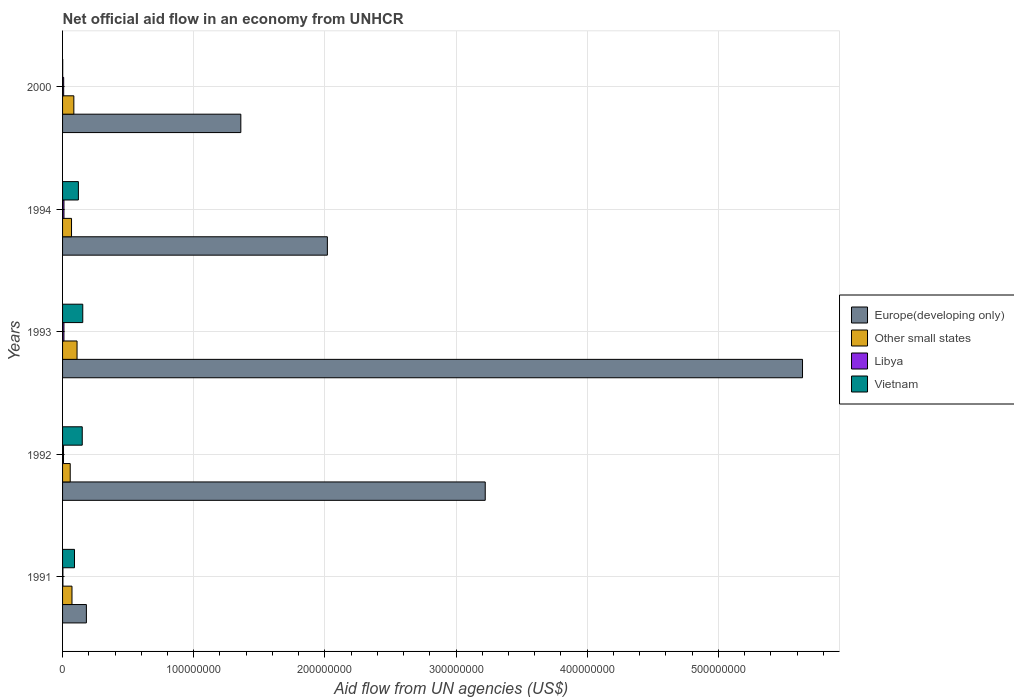How many different coloured bars are there?
Ensure brevity in your answer.  4. Are the number of bars per tick equal to the number of legend labels?
Your answer should be compact. Yes. Are the number of bars on each tick of the Y-axis equal?
Give a very brief answer. Yes. How many bars are there on the 1st tick from the top?
Give a very brief answer. 4. How many bars are there on the 4th tick from the bottom?
Offer a very short reply. 4. What is the net official aid flow in Other small states in 2000?
Your response must be concise. 8.60e+06. Across all years, what is the maximum net official aid flow in Europe(developing only)?
Your answer should be very brief. 5.64e+08. In which year was the net official aid flow in Other small states minimum?
Your answer should be very brief. 1992. What is the total net official aid flow in Libya in the graph?
Offer a terse response. 3.96e+06. What is the difference between the net official aid flow in Other small states in 1992 and that in 1994?
Your response must be concise. -9.90e+05. What is the difference between the net official aid flow in Libya in 1993 and the net official aid flow in Europe(developing only) in 1991?
Ensure brevity in your answer.  -1.71e+07. What is the average net official aid flow in Vietnam per year?
Offer a terse response. 1.03e+07. In the year 1991, what is the difference between the net official aid flow in Libya and net official aid flow in Europe(developing only)?
Provide a succinct answer. -1.79e+07. What is the ratio of the net official aid flow in Europe(developing only) in 1992 to that in 2000?
Make the answer very short. 2.37. Is the net official aid flow in Other small states in 1993 less than that in 2000?
Make the answer very short. No. Is the difference between the net official aid flow in Libya in 1991 and 2000 greater than the difference between the net official aid flow in Europe(developing only) in 1991 and 2000?
Provide a succinct answer. Yes. What is the difference between the highest and the second highest net official aid flow in Vietnam?
Keep it short and to the point. 3.90e+05. What is the difference between the highest and the lowest net official aid flow in Other small states?
Make the answer very short. 5.20e+06. In how many years, is the net official aid flow in Libya greater than the average net official aid flow in Libya taken over all years?
Provide a short and direct response. 3. Is it the case that in every year, the sum of the net official aid flow in Other small states and net official aid flow in Libya is greater than the sum of net official aid flow in Europe(developing only) and net official aid flow in Vietnam?
Ensure brevity in your answer.  No. What does the 4th bar from the top in 1994 represents?
Keep it short and to the point. Europe(developing only). What does the 4th bar from the bottom in 1991 represents?
Offer a very short reply. Vietnam. Are all the bars in the graph horizontal?
Offer a terse response. Yes. How many years are there in the graph?
Offer a terse response. 5. Are the values on the major ticks of X-axis written in scientific E-notation?
Offer a terse response. No. Where does the legend appear in the graph?
Offer a terse response. Center right. How are the legend labels stacked?
Your answer should be very brief. Vertical. What is the title of the graph?
Provide a succinct answer. Net official aid flow in an economy from UNHCR. Does "Zimbabwe" appear as one of the legend labels in the graph?
Offer a very short reply. No. What is the label or title of the X-axis?
Your response must be concise. Aid flow from UN agencies (US$). What is the Aid flow from UN agencies (US$) in Europe(developing only) in 1991?
Offer a very short reply. 1.82e+07. What is the Aid flow from UN agencies (US$) in Other small states in 1991?
Provide a succinct answer. 7.18e+06. What is the Aid flow from UN agencies (US$) of Vietnam in 1991?
Provide a succinct answer. 9.10e+06. What is the Aid flow from UN agencies (US$) of Europe(developing only) in 1992?
Ensure brevity in your answer.  3.22e+08. What is the Aid flow from UN agencies (US$) of Other small states in 1992?
Your response must be concise. 5.84e+06. What is the Aid flow from UN agencies (US$) of Libya in 1992?
Offer a very short reply. 7.30e+05. What is the Aid flow from UN agencies (US$) of Vietnam in 1992?
Keep it short and to the point. 1.50e+07. What is the Aid flow from UN agencies (US$) in Europe(developing only) in 1993?
Your answer should be very brief. 5.64e+08. What is the Aid flow from UN agencies (US$) in Other small states in 1993?
Keep it short and to the point. 1.10e+07. What is the Aid flow from UN agencies (US$) of Libya in 1993?
Your answer should be compact. 1.05e+06. What is the Aid flow from UN agencies (US$) of Vietnam in 1993?
Make the answer very short. 1.54e+07. What is the Aid flow from UN agencies (US$) in Europe(developing only) in 1994?
Your answer should be very brief. 2.02e+08. What is the Aid flow from UN agencies (US$) of Other small states in 1994?
Your response must be concise. 6.83e+06. What is the Aid flow from UN agencies (US$) of Libya in 1994?
Offer a very short reply. 1.07e+06. What is the Aid flow from UN agencies (US$) of Vietnam in 1994?
Provide a succinct answer. 1.21e+07. What is the Aid flow from UN agencies (US$) in Europe(developing only) in 2000?
Make the answer very short. 1.36e+08. What is the Aid flow from UN agencies (US$) of Other small states in 2000?
Provide a succinct answer. 8.60e+06. What is the Aid flow from UN agencies (US$) of Libya in 2000?
Keep it short and to the point. 8.40e+05. Across all years, what is the maximum Aid flow from UN agencies (US$) in Europe(developing only)?
Provide a succinct answer. 5.64e+08. Across all years, what is the maximum Aid flow from UN agencies (US$) in Other small states?
Provide a short and direct response. 1.10e+07. Across all years, what is the maximum Aid flow from UN agencies (US$) in Libya?
Provide a short and direct response. 1.07e+06. Across all years, what is the maximum Aid flow from UN agencies (US$) in Vietnam?
Provide a short and direct response. 1.54e+07. Across all years, what is the minimum Aid flow from UN agencies (US$) of Europe(developing only)?
Your answer should be very brief. 1.82e+07. Across all years, what is the minimum Aid flow from UN agencies (US$) of Other small states?
Your answer should be compact. 5.84e+06. What is the total Aid flow from UN agencies (US$) of Europe(developing only) in the graph?
Give a very brief answer. 1.24e+09. What is the total Aid flow from UN agencies (US$) in Other small states in the graph?
Offer a very short reply. 3.95e+07. What is the total Aid flow from UN agencies (US$) of Libya in the graph?
Offer a very short reply. 3.96e+06. What is the total Aid flow from UN agencies (US$) of Vietnam in the graph?
Your answer should be very brief. 5.17e+07. What is the difference between the Aid flow from UN agencies (US$) of Europe(developing only) in 1991 and that in 1992?
Your response must be concise. -3.04e+08. What is the difference between the Aid flow from UN agencies (US$) in Other small states in 1991 and that in 1992?
Offer a terse response. 1.34e+06. What is the difference between the Aid flow from UN agencies (US$) in Libya in 1991 and that in 1992?
Offer a terse response. -4.60e+05. What is the difference between the Aid flow from UN agencies (US$) in Vietnam in 1991 and that in 1992?
Keep it short and to the point. -5.91e+06. What is the difference between the Aid flow from UN agencies (US$) in Europe(developing only) in 1991 and that in 1993?
Keep it short and to the point. -5.46e+08. What is the difference between the Aid flow from UN agencies (US$) of Other small states in 1991 and that in 1993?
Keep it short and to the point. -3.86e+06. What is the difference between the Aid flow from UN agencies (US$) of Libya in 1991 and that in 1993?
Your answer should be very brief. -7.80e+05. What is the difference between the Aid flow from UN agencies (US$) of Vietnam in 1991 and that in 1993?
Your answer should be compact. -6.30e+06. What is the difference between the Aid flow from UN agencies (US$) in Europe(developing only) in 1991 and that in 1994?
Provide a succinct answer. -1.84e+08. What is the difference between the Aid flow from UN agencies (US$) of Other small states in 1991 and that in 1994?
Keep it short and to the point. 3.50e+05. What is the difference between the Aid flow from UN agencies (US$) of Libya in 1991 and that in 1994?
Give a very brief answer. -8.00e+05. What is the difference between the Aid flow from UN agencies (US$) in Vietnam in 1991 and that in 1994?
Make the answer very short. -2.97e+06. What is the difference between the Aid flow from UN agencies (US$) in Europe(developing only) in 1991 and that in 2000?
Offer a terse response. -1.18e+08. What is the difference between the Aid flow from UN agencies (US$) of Other small states in 1991 and that in 2000?
Provide a short and direct response. -1.42e+06. What is the difference between the Aid flow from UN agencies (US$) of Libya in 1991 and that in 2000?
Provide a succinct answer. -5.70e+05. What is the difference between the Aid flow from UN agencies (US$) of Vietnam in 1991 and that in 2000?
Your answer should be compact. 8.99e+06. What is the difference between the Aid flow from UN agencies (US$) in Europe(developing only) in 1992 and that in 1993?
Provide a succinct answer. -2.42e+08. What is the difference between the Aid flow from UN agencies (US$) in Other small states in 1992 and that in 1993?
Make the answer very short. -5.20e+06. What is the difference between the Aid flow from UN agencies (US$) of Libya in 1992 and that in 1993?
Make the answer very short. -3.20e+05. What is the difference between the Aid flow from UN agencies (US$) of Vietnam in 1992 and that in 1993?
Make the answer very short. -3.90e+05. What is the difference between the Aid flow from UN agencies (US$) in Europe(developing only) in 1992 and that in 1994?
Ensure brevity in your answer.  1.20e+08. What is the difference between the Aid flow from UN agencies (US$) of Other small states in 1992 and that in 1994?
Offer a very short reply. -9.90e+05. What is the difference between the Aid flow from UN agencies (US$) in Libya in 1992 and that in 1994?
Provide a short and direct response. -3.40e+05. What is the difference between the Aid flow from UN agencies (US$) of Vietnam in 1992 and that in 1994?
Offer a terse response. 2.94e+06. What is the difference between the Aid flow from UN agencies (US$) in Europe(developing only) in 1992 and that in 2000?
Your answer should be compact. 1.86e+08. What is the difference between the Aid flow from UN agencies (US$) of Other small states in 1992 and that in 2000?
Provide a short and direct response. -2.76e+06. What is the difference between the Aid flow from UN agencies (US$) in Libya in 1992 and that in 2000?
Offer a very short reply. -1.10e+05. What is the difference between the Aid flow from UN agencies (US$) in Vietnam in 1992 and that in 2000?
Your answer should be very brief. 1.49e+07. What is the difference between the Aid flow from UN agencies (US$) in Europe(developing only) in 1993 and that in 1994?
Provide a succinct answer. 3.62e+08. What is the difference between the Aid flow from UN agencies (US$) in Other small states in 1993 and that in 1994?
Keep it short and to the point. 4.21e+06. What is the difference between the Aid flow from UN agencies (US$) of Vietnam in 1993 and that in 1994?
Keep it short and to the point. 3.33e+06. What is the difference between the Aid flow from UN agencies (US$) in Europe(developing only) in 1993 and that in 2000?
Give a very brief answer. 4.28e+08. What is the difference between the Aid flow from UN agencies (US$) of Other small states in 1993 and that in 2000?
Your response must be concise. 2.44e+06. What is the difference between the Aid flow from UN agencies (US$) of Libya in 1993 and that in 2000?
Your answer should be compact. 2.10e+05. What is the difference between the Aid flow from UN agencies (US$) of Vietnam in 1993 and that in 2000?
Offer a terse response. 1.53e+07. What is the difference between the Aid flow from UN agencies (US$) in Europe(developing only) in 1994 and that in 2000?
Your response must be concise. 6.60e+07. What is the difference between the Aid flow from UN agencies (US$) in Other small states in 1994 and that in 2000?
Ensure brevity in your answer.  -1.77e+06. What is the difference between the Aid flow from UN agencies (US$) in Libya in 1994 and that in 2000?
Your response must be concise. 2.30e+05. What is the difference between the Aid flow from UN agencies (US$) in Vietnam in 1994 and that in 2000?
Offer a very short reply. 1.20e+07. What is the difference between the Aid flow from UN agencies (US$) in Europe(developing only) in 1991 and the Aid flow from UN agencies (US$) in Other small states in 1992?
Keep it short and to the point. 1.23e+07. What is the difference between the Aid flow from UN agencies (US$) in Europe(developing only) in 1991 and the Aid flow from UN agencies (US$) in Libya in 1992?
Your answer should be very brief. 1.74e+07. What is the difference between the Aid flow from UN agencies (US$) in Europe(developing only) in 1991 and the Aid flow from UN agencies (US$) in Vietnam in 1992?
Offer a terse response. 3.15e+06. What is the difference between the Aid flow from UN agencies (US$) of Other small states in 1991 and the Aid flow from UN agencies (US$) of Libya in 1992?
Offer a very short reply. 6.45e+06. What is the difference between the Aid flow from UN agencies (US$) of Other small states in 1991 and the Aid flow from UN agencies (US$) of Vietnam in 1992?
Your answer should be compact. -7.83e+06. What is the difference between the Aid flow from UN agencies (US$) of Libya in 1991 and the Aid flow from UN agencies (US$) of Vietnam in 1992?
Make the answer very short. -1.47e+07. What is the difference between the Aid flow from UN agencies (US$) in Europe(developing only) in 1991 and the Aid flow from UN agencies (US$) in Other small states in 1993?
Your answer should be compact. 7.12e+06. What is the difference between the Aid flow from UN agencies (US$) in Europe(developing only) in 1991 and the Aid flow from UN agencies (US$) in Libya in 1993?
Your response must be concise. 1.71e+07. What is the difference between the Aid flow from UN agencies (US$) of Europe(developing only) in 1991 and the Aid flow from UN agencies (US$) of Vietnam in 1993?
Keep it short and to the point. 2.76e+06. What is the difference between the Aid flow from UN agencies (US$) in Other small states in 1991 and the Aid flow from UN agencies (US$) in Libya in 1993?
Your answer should be very brief. 6.13e+06. What is the difference between the Aid flow from UN agencies (US$) of Other small states in 1991 and the Aid flow from UN agencies (US$) of Vietnam in 1993?
Make the answer very short. -8.22e+06. What is the difference between the Aid flow from UN agencies (US$) in Libya in 1991 and the Aid flow from UN agencies (US$) in Vietnam in 1993?
Provide a succinct answer. -1.51e+07. What is the difference between the Aid flow from UN agencies (US$) of Europe(developing only) in 1991 and the Aid flow from UN agencies (US$) of Other small states in 1994?
Ensure brevity in your answer.  1.13e+07. What is the difference between the Aid flow from UN agencies (US$) in Europe(developing only) in 1991 and the Aid flow from UN agencies (US$) in Libya in 1994?
Give a very brief answer. 1.71e+07. What is the difference between the Aid flow from UN agencies (US$) in Europe(developing only) in 1991 and the Aid flow from UN agencies (US$) in Vietnam in 1994?
Offer a terse response. 6.09e+06. What is the difference between the Aid flow from UN agencies (US$) of Other small states in 1991 and the Aid flow from UN agencies (US$) of Libya in 1994?
Offer a very short reply. 6.11e+06. What is the difference between the Aid flow from UN agencies (US$) in Other small states in 1991 and the Aid flow from UN agencies (US$) in Vietnam in 1994?
Offer a very short reply. -4.89e+06. What is the difference between the Aid flow from UN agencies (US$) in Libya in 1991 and the Aid flow from UN agencies (US$) in Vietnam in 1994?
Make the answer very short. -1.18e+07. What is the difference between the Aid flow from UN agencies (US$) of Europe(developing only) in 1991 and the Aid flow from UN agencies (US$) of Other small states in 2000?
Make the answer very short. 9.56e+06. What is the difference between the Aid flow from UN agencies (US$) in Europe(developing only) in 1991 and the Aid flow from UN agencies (US$) in Libya in 2000?
Your response must be concise. 1.73e+07. What is the difference between the Aid flow from UN agencies (US$) in Europe(developing only) in 1991 and the Aid flow from UN agencies (US$) in Vietnam in 2000?
Make the answer very short. 1.80e+07. What is the difference between the Aid flow from UN agencies (US$) of Other small states in 1991 and the Aid flow from UN agencies (US$) of Libya in 2000?
Offer a very short reply. 6.34e+06. What is the difference between the Aid flow from UN agencies (US$) in Other small states in 1991 and the Aid flow from UN agencies (US$) in Vietnam in 2000?
Provide a short and direct response. 7.07e+06. What is the difference between the Aid flow from UN agencies (US$) in Europe(developing only) in 1992 and the Aid flow from UN agencies (US$) in Other small states in 1993?
Your answer should be compact. 3.11e+08. What is the difference between the Aid flow from UN agencies (US$) in Europe(developing only) in 1992 and the Aid flow from UN agencies (US$) in Libya in 1993?
Give a very brief answer. 3.21e+08. What is the difference between the Aid flow from UN agencies (US$) in Europe(developing only) in 1992 and the Aid flow from UN agencies (US$) in Vietnam in 1993?
Ensure brevity in your answer.  3.07e+08. What is the difference between the Aid flow from UN agencies (US$) of Other small states in 1992 and the Aid flow from UN agencies (US$) of Libya in 1993?
Offer a terse response. 4.79e+06. What is the difference between the Aid flow from UN agencies (US$) of Other small states in 1992 and the Aid flow from UN agencies (US$) of Vietnam in 1993?
Your answer should be compact. -9.56e+06. What is the difference between the Aid flow from UN agencies (US$) of Libya in 1992 and the Aid flow from UN agencies (US$) of Vietnam in 1993?
Keep it short and to the point. -1.47e+07. What is the difference between the Aid flow from UN agencies (US$) of Europe(developing only) in 1992 and the Aid flow from UN agencies (US$) of Other small states in 1994?
Your answer should be compact. 3.15e+08. What is the difference between the Aid flow from UN agencies (US$) in Europe(developing only) in 1992 and the Aid flow from UN agencies (US$) in Libya in 1994?
Provide a succinct answer. 3.21e+08. What is the difference between the Aid flow from UN agencies (US$) in Europe(developing only) in 1992 and the Aid flow from UN agencies (US$) in Vietnam in 1994?
Provide a succinct answer. 3.10e+08. What is the difference between the Aid flow from UN agencies (US$) of Other small states in 1992 and the Aid flow from UN agencies (US$) of Libya in 1994?
Ensure brevity in your answer.  4.77e+06. What is the difference between the Aid flow from UN agencies (US$) in Other small states in 1992 and the Aid flow from UN agencies (US$) in Vietnam in 1994?
Your response must be concise. -6.23e+06. What is the difference between the Aid flow from UN agencies (US$) in Libya in 1992 and the Aid flow from UN agencies (US$) in Vietnam in 1994?
Your answer should be very brief. -1.13e+07. What is the difference between the Aid flow from UN agencies (US$) in Europe(developing only) in 1992 and the Aid flow from UN agencies (US$) in Other small states in 2000?
Your answer should be compact. 3.14e+08. What is the difference between the Aid flow from UN agencies (US$) of Europe(developing only) in 1992 and the Aid flow from UN agencies (US$) of Libya in 2000?
Make the answer very short. 3.21e+08. What is the difference between the Aid flow from UN agencies (US$) in Europe(developing only) in 1992 and the Aid flow from UN agencies (US$) in Vietnam in 2000?
Your answer should be very brief. 3.22e+08. What is the difference between the Aid flow from UN agencies (US$) of Other small states in 1992 and the Aid flow from UN agencies (US$) of Vietnam in 2000?
Offer a very short reply. 5.73e+06. What is the difference between the Aid flow from UN agencies (US$) in Libya in 1992 and the Aid flow from UN agencies (US$) in Vietnam in 2000?
Offer a very short reply. 6.20e+05. What is the difference between the Aid flow from UN agencies (US$) in Europe(developing only) in 1993 and the Aid flow from UN agencies (US$) in Other small states in 1994?
Offer a very short reply. 5.57e+08. What is the difference between the Aid flow from UN agencies (US$) in Europe(developing only) in 1993 and the Aid flow from UN agencies (US$) in Libya in 1994?
Make the answer very short. 5.63e+08. What is the difference between the Aid flow from UN agencies (US$) in Europe(developing only) in 1993 and the Aid flow from UN agencies (US$) in Vietnam in 1994?
Your answer should be compact. 5.52e+08. What is the difference between the Aid flow from UN agencies (US$) in Other small states in 1993 and the Aid flow from UN agencies (US$) in Libya in 1994?
Provide a succinct answer. 9.97e+06. What is the difference between the Aid flow from UN agencies (US$) of Other small states in 1993 and the Aid flow from UN agencies (US$) of Vietnam in 1994?
Offer a very short reply. -1.03e+06. What is the difference between the Aid flow from UN agencies (US$) of Libya in 1993 and the Aid flow from UN agencies (US$) of Vietnam in 1994?
Keep it short and to the point. -1.10e+07. What is the difference between the Aid flow from UN agencies (US$) of Europe(developing only) in 1993 and the Aid flow from UN agencies (US$) of Other small states in 2000?
Your answer should be very brief. 5.56e+08. What is the difference between the Aid flow from UN agencies (US$) of Europe(developing only) in 1993 and the Aid flow from UN agencies (US$) of Libya in 2000?
Ensure brevity in your answer.  5.63e+08. What is the difference between the Aid flow from UN agencies (US$) of Europe(developing only) in 1993 and the Aid flow from UN agencies (US$) of Vietnam in 2000?
Your response must be concise. 5.64e+08. What is the difference between the Aid flow from UN agencies (US$) of Other small states in 1993 and the Aid flow from UN agencies (US$) of Libya in 2000?
Ensure brevity in your answer.  1.02e+07. What is the difference between the Aid flow from UN agencies (US$) in Other small states in 1993 and the Aid flow from UN agencies (US$) in Vietnam in 2000?
Make the answer very short. 1.09e+07. What is the difference between the Aid flow from UN agencies (US$) of Libya in 1993 and the Aid flow from UN agencies (US$) of Vietnam in 2000?
Offer a very short reply. 9.40e+05. What is the difference between the Aid flow from UN agencies (US$) in Europe(developing only) in 1994 and the Aid flow from UN agencies (US$) in Other small states in 2000?
Offer a very short reply. 1.93e+08. What is the difference between the Aid flow from UN agencies (US$) in Europe(developing only) in 1994 and the Aid flow from UN agencies (US$) in Libya in 2000?
Ensure brevity in your answer.  2.01e+08. What is the difference between the Aid flow from UN agencies (US$) in Europe(developing only) in 1994 and the Aid flow from UN agencies (US$) in Vietnam in 2000?
Offer a terse response. 2.02e+08. What is the difference between the Aid flow from UN agencies (US$) in Other small states in 1994 and the Aid flow from UN agencies (US$) in Libya in 2000?
Offer a very short reply. 5.99e+06. What is the difference between the Aid flow from UN agencies (US$) in Other small states in 1994 and the Aid flow from UN agencies (US$) in Vietnam in 2000?
Offer a very short reply. 6.72e+06. What is the difference between the Aid flow from UN agencies (US$) in Libya in 1994 and the Aid flow from UN agencies (US$) in Vietnam in 2000?
Offer a terse response. 9.60e+05. What is the average Aid flow from UN agencies (US$) of Europe(developing only) per year?
Ensure brevity in your answer.  2.48e+08. What is the average Aid flow from UN agencies (US$) of Other small states per year?
Make the answer very short. 7.90e+06. What is the average Aid flow from UN agencies (US$) of Libya per year?
Ensure brevity in your answer.  7.92e+05. What is the average Aid flow from UN agencies (US$) in Vietnam per year?
Your answer should be compact. 1.03e+07. In the year 1991, what is the difference between the Aid flow from UN agencies (US$) in Europe(developing only) and Aid flow from UN agencies (US$) in Other small states?
Make the answer very short. 1.10e+07. In the year 1991, what is the difference between the Aid flow from UN agencies (US$) of Europe(developing only) and Aid flow from UN agencies (US$) of Libya?
Your response must be concise. 1.79e+07. In the year 1991, what is the difference between the Aid flow from UN agencies (US$) in Europe(developing only) and Aid flow from UN agencies (US$) in Vietnam?
Provide a short and direct response. 9.06e+06. In the year 1991, what is the difference between the Aid flow from UN agencies (US$) of Other small states and Aid flow from UN agencies (US$) of Libya?
Provide a succinct answer. 6.91e+06. In the year 1991, what is the difference between the Aid flow from UN agencies (US$) of Other small states and Aid flow from UN agencies (US$) of Vietnam?
Offer a very short reply. -1.92e+06. In the year 1991, what is the difference between the Aid flow from UN agencies (US$) of Libya and Aid flow from UN agencies (US$) of Vietnam?
Give a very brief answer. -8.83e+06. In the year 1992, what is the difference between the Aid flow from UN agencies (US$) in Europe(developing only) and Aid flow from UN agencies (US$) in Other small states?
Make the answer very short. 3.16e+08. In the year 1992, what is the difference between the Aid flow from UN agencies (US$) of Europe(developing only) and Aid flow from UN agencies (US$) of Libya?
Offer a very short reply. 3.22e+08. In the year 1992, what is the difference between the Aid flow from UN agencies (US$) of Europe(developing only) and Aid flow from UN agencies (US$) of Vietnam?
Make the answer very short. 3.07e+08. In the year 1992, what is the difference between the Aid flow from UN agencies (US$) of Other small states and Aid flow from UN agencies (US$) of Libya?
Your answer should be very brief. 5.11e+06. In the year 1992, what is the difference between the Aid flow from UN agencies (US$) of Other small states and Aid flow from UN agencies (US$) of Vietnam?
Provide a short and direct response. -9.17e+06. In the year 1992, what is the difference between the Aid flow from UN agencies (US$) of Libya and Aid flow from UN agencies (US$) of Vietnam?
Keep it short and to the point. -1.43e+07. In the year 1993, what is the difference between the Aid flow from UN agencies (US$) of Europe(developing only) and Aid flow from UN agencies (US$) of Other small states?
Keep it short and to the point. 5.53e+08. In the year 1993, what is the difference between the Aid flow from UN agencies (US$) in Europe(developing only) and Aid flow from UN agencies (US$) in Libya?
Make the answer very short. 5.63e+08. In the year 1993, what is the difference between the Aid flow from UN agencies (US$) in Europe(developing only) and Aid flow from UN agencies (US$) in Vietnam?
Ensure brevity in your answer.  5.49e+08. In the year 1993, what is the difference between the Aid flow from UN agencies (US$) of Other small states and Aid flow from UN agencies (US$) of Libya?
Give a very brief answer. 9.99e+06. In the year 1993, what is the difference between the Aid flow from UN agencies (US$) in Other small states and Aid flow from UN agencies (US$) in Vietnam?
Your answer should be compact. -4.36e+06. In the year 1993, what is the difference between the Aid flow from UN agencies (US$) of Libya and Aid flow from UN agencies (US$) of Vietnam?
Offer a very short reply. -1.44e+07. In the year 1994, what is the difference between the Aid flow from UN agencies (US$) in Europe(developing only) and Aid flow from UN agencies (US$) in Other small states?
Give a very brief answer. 1.95e+08. In the year 1994, what is the difference between the Aid flow from UN agencies (US$) in Europe(developing only) and Aid flow from UN agencies (US$) in Libya?
Give a very brief answer. 2.01e+08. In the year 1994, what is the difference between the Aid flow from UN agencies (US$) in Europe(developing only) and Aid flow from UN agencies (US$) in Vietnam?
Give a very brief answer. 1.90e+08. In the year 1994, what is the difference between the Aid flow from UN agencies (US$) in Other small states and Aid flow from UN agencies (US$) in Libya?
Provide a short and direct response. 5.76e+06. In the year 1994, what is the difference between the Aid flow from UN agencies (US$) in Other small states and Aid flow from UN agencies (US$) in Vietnam?
Keep it short and to the point. -5.24e+06. In the year 1994, what is the difference between the Aid flow from UN agencies (US$) of Libya and Aid flow from UN agencies (US$) of Vietnam?
Make the answer very short. -1.10e+07. In the year 2000, what is the difference between the Aid flow from UN agencies (US$) in Europe(developing only) and Aid flow from UN agencies (US$) in Other small states?
Give a very brief answer. 1.27e+08. In the year 2000, what is the difference between the Aid flow from UN agencies (US$) of Europe(developing only) and Aid flow from UN agencies (US$) of Libya?
Provide a short and direct response. 1.35e+08. In the year 2000, what is the difference between the Aid flow from UN agencies (US$) in Europe(developing only) and Aid flow from UN agencies (US$) in Vietnam?
Offer a terse response. 1.36e+08. In the year 2000, what is the difference between the Aid flow from UN agencies (US$) of Other small states and Aid flow from UN agencies (US$) of Libya?
Keep it short and to the point. 7.76e+06. In the year 2000, what is the difference between the Aid flow from UN agencies (US$) of Other small states and Aid flow from UN agencies (US$) of Vietnam?
Keep it short and to the point. 8.49e+06. In the year 2000, what is the difference between the Aid flow from UN agencies (US$) of Libya and Aid flow from UN agencies (US$) of Vietnam?
Provide a succinct answer. 7.30e+05. What is the ratio of the Aid flow from UN agencies (US$) in Europe(developing only) in 1991 to that in 1992?
Your answer should be very brief. 0.06. What is the ratio of the Aid flow from UN agencies (US$) of Other small states in 1991 to that in 1992?
Provide a short and direct response. 1.23. What is the ratio of the Aid flow from UN agencies (US$) in Libya in 1991 to that in 1992?
Provide a succinct answer. 0.37. What is the ratio of the Aid flow from UN agencies (US$) of Vietnam in 1991 to that in 1992?
Offer a very short reply. 0.61. What is the ratio of the Aid flow from UN agencies (US$) in Europe(developing only) in 1991 to that in 1993?
Provide a succinct answer. 0.03. What is the ratio of the Aid flow from UN agencies (US$) in Other small states in 1991 to that in 1993?
Provide a short and direct response. 0.65. What is the ratio of the Aid flow from UN agencies (US$) of Libya in 1991 to that in 1993?
Your answer should be compact. 0.26. What is the ratio of the Aid flow from UN agencies (US$) of Vietnam in 1991 to that in 1993?
Ensure brevity in your answer.  0.59. What is the ratio of the Aid flow from UN agencies (US$) of Europe(developing only) in 1991 to that in 1994?
Ensure brevity in your answer.  0.09. What is the ratio of the Aid flow from UN agencies (US$) in Other small states in 1991 to that in 1994?
Your response must be concise. 1.05. What is the ratio of the Aid flow from UN agencies (US$) in Libya in 1991 to that in 1994?
Provide a succinct answer. 0.25. What is the ratio of the Aid flow from UN agencies (US$) in Vietnam in 1991 to that in 1994?
Provide a succinct answer. 0.75. What is the ratio of the Aid flow from UN agencies (US$) of Europe(developing only) in 1991 to that in 2000?
Your response must be concise. 0.13. What is the ratio of the Aid flow from UN agencies (US$) in Other small states in 1991 to that in 2000?
Ensure brevity in your answer.  0.83. What is the ratio of the Aid flow from UN agencies (US$) in Libya in 1991 to that in 2000?
Your answer should be compact. 0.32. What is the ratio of the Aid flow from UN agencies (US$) of Vietnam in 1991 to that in 2000?
Give a very brief answer. 82.73. What is the ratio of the Aid flow from UN agencies (US$) of Europe(developing only) in 1992 to that in 1993?
Your answer should be very brief. 0.57. What is the ratio of the Aid flow from UN agencies (US$) in Other small states in 1992 to that in 1993?
Give a very brief answer. 0.53. What is the ratio of the Aid flow from UN agencies (US$) in Libya in 1992 to that in 1993?
Make the answer very short. 0.7. What is the ratio of the Aid flow from UN agencies (US$) of Vietnam in 1992 to that in 1993?
Offer a terse response. 0.97. What is the ratio of the Aid flow from UN agencies (US$) of Europe(developing only) in 1992 to that in 1994?
Make the answer very short. 1.6. What is the ratio of the Aid flow from UN agencies (US$) of Other small states in 1992 to that in 1994?
Your response must be concise. 0.86. What is the ratio of the Aid flow from UN agencies (US$) of Libya in 1992 to that in 1994?
Keep it short and to the point. 0.68. What is the ratio of the Aid flow from UN agencies (US$) of Vietnam in 1992 to that in 1994?
Provide a succinct answer. 1.24. What is the ratio of the Aid flow from UN agencies (US$) of Europe(developing only) in 1992 to that in 2000?
Offer a terse response. 2.37. What is the ratio of the Aid flow from UN agencies (US$) in Other small states in 1992 to that in 2000?
Provide a succinct answer. 0.68. What is the ratio of the Aid flow from UN agencies (US$) in Libya in 1992 to that in 2000?
Offer a very short reply. 0.87. What is the ratio of the Aid flow from UN agencies (US$) of Vietnam in 1992 to that in 2000?
Give a very brief answer. 136.45. What is the ratio of the Aid flow from UN agencies (US$) in Europe(developing only) in 1993 to that in 1994?
Your response must be concise. 2.79. What is the ratio of the Aid flow from UN agencies (US$) of Other small states in 1993 to that in 1994?
Make the answer very short. 1.62. What is the ratio of the Aid flow from UN agencies (US$) in Libya in 1993 to that in 1994?
Your response must be concise. 0.98. What is the ratio of the Aid flow from UN agencies (US$) of Vietnam in 1993 to that in 1994?
Give a very brief answer. 1.28. What is the ratio of the Aid flow from UN agencies (US$) in Europe(developing only) in 1993 to that in 2000?
Offer a very short reply. 4.15. What is the ratio of the Aid flow from UN agencies (US$) in Other small states in 1993 to that in 2000?
Provide a short and direct response. 1.28. What is the ratio of the Aid flow from UN agencies (US$) in Vietnam in 1993 to that in 2000?
Your response must be concise. 140. What is the ratio of the Aid flow from UN agencies (US$) of Europe(developing only) in 1994 to that in 2000?
Your answer should be compact. 1.49. What is the ratio of the Aid flow from UN agencies (US$) in Other small states in 1994 to that in 2000?
Provide a short and direct response. 0.79. What is the ratio of the Aid flow from UN agencies (US$) in Libya in 1994 to that in 2000?
Offer a very short reply. 1.27. What is the ratio of the Aid flow from UN agencies (US$) of Vietnam in 1994 to that in 2000?
Offer a very short reply. 109.73. What is the difference between the highest and the second highest Aid flow from UN agencies (US$) of Europe(developing only)?
Your answer should be very brief. 2.42e+08. What is the difference between the highest and the second highest Aid flow from UN agencies (US$) of Other small states?
Offer a very short reply. 2.44e+06. What is the difference between the highest and the second highest Aid flow from UN agencies (US$) in Libya?
Your response must be concise. 2.00e+04. What is the difference between the highest and the second highest Aid flow from UN agencies (US$) of Vietnam?
Your answer should be compact. 3.90e+05. What is the difference between the highest and the lowest Aid flow from UN agencies (US$) in Europe(developing only)?
Ensure brevity in your answer.  5.46e+08. What is the difference between the highest and the lowest Aid flow from UN agencies (US$) of Other small states?
Keep it short and to the point. 5.20e+06. What is the difference between the highest and the lowest Aid flow from UN agencies (US$) of Vietnam?
Offer a terse response. 1.53e+07. 